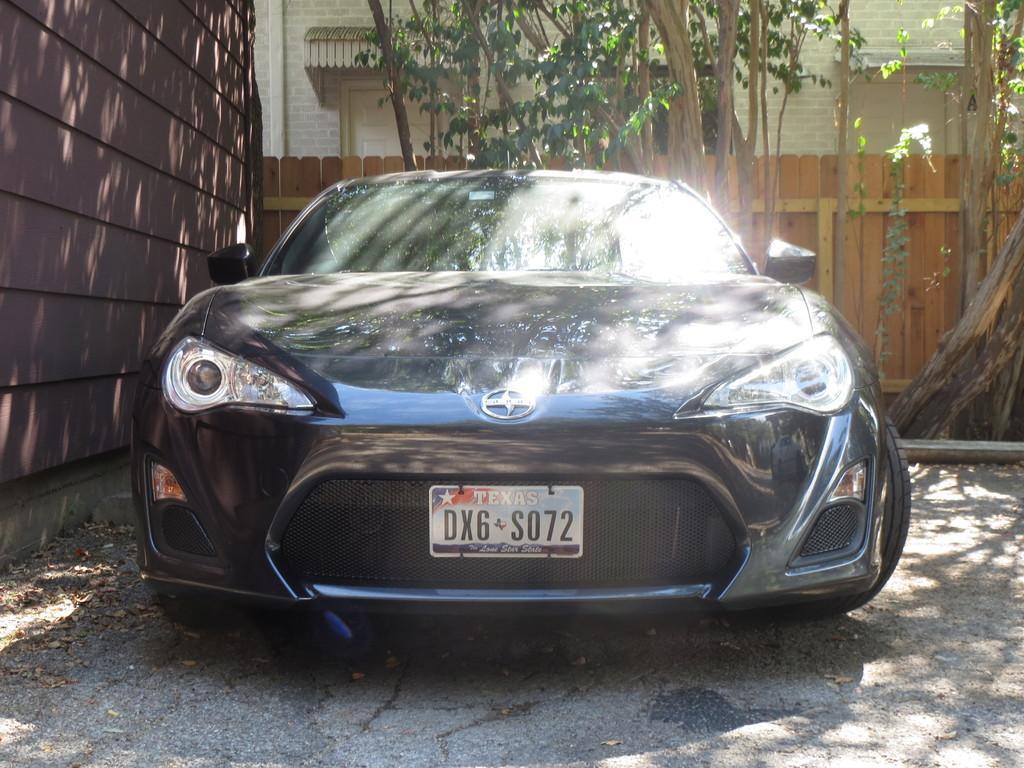Can you describe this image briefly? In this image I can see there is a car, on the left side it is the wall, at the back side there are trees. 